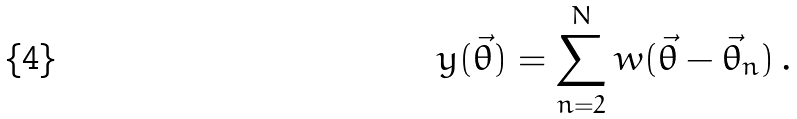Convert formula to latex. <formula><loc_0><loc_0><loc_500><loc_500>y ( \vec { \theta } ) = \sum _ { n = 2 } ^ { N } w ( \vec { \theta } - \vec { \theta } _ { n } ) \, .</formula> 